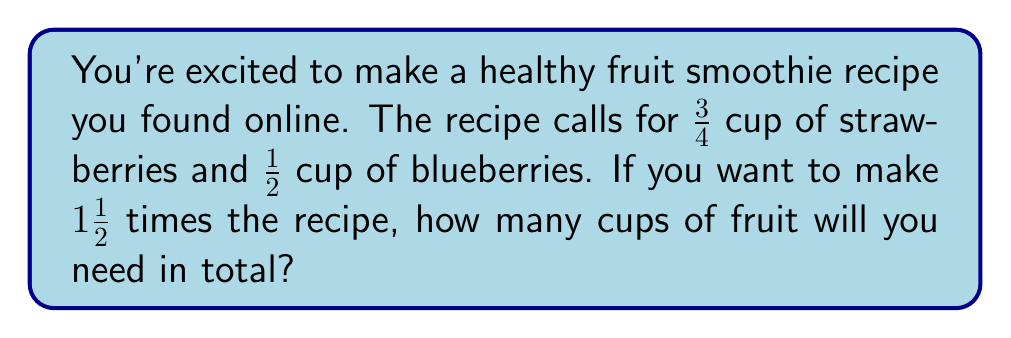Can you solve this math problem? Let's approach this step-by-step:

1) First, let's calculate the new amount for each fruit:

   For strawberries:
   $\frac{3}{4} \times 1\frac{1}{2} = \frac{3}{4} \times \frac{3}{2} = \frac{9}{8} = 1\frac{1}{8}$ cups

   For blueberries:
   $\frac{1}{2} \times 1\frac{1}{2} = \frac{1}{2} \times \frac{3}{2} = \frac{3}{4}$ cups

2) Now, we need to add these amounts together:

   $1\frac{1}{8} + \frac{3}{4}$

3) To add fractions, we need a common denominator. The least common multiple of 8 and 4 is 8, so we'll convert $\frac{3}{4}$ to eighths:

   $\frac{3}{4} = \frac{6}{8}$

4) Now we can add:

   $1\frac{1}{8} + \frac{6}{8} = 1 + \frac{1}{8} + \frac{6}{8} = 1 + \frac{7}{8} = 1\frac{7}{8}$

Therefore, you will need $1\frac{7}{8}$ cups of fruit in total.
Answer: $1\frac{7}{8}$ cups 